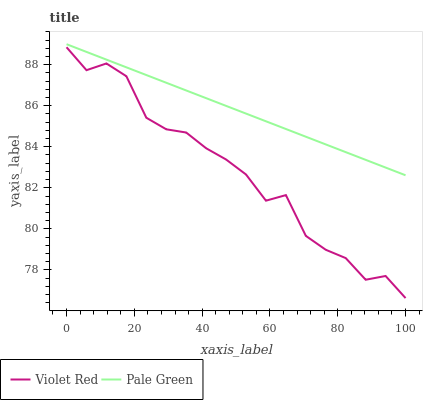Does Violet Red have the minimum area under the curve?
Answer yes or no. Yes. Does Pale Green have the maximum area under the curve?
Answer yes or no. Yes. Does Pale Green have the minimum area under the curve?
Answer yes or no. No. Is Pale Green the smoothest?
Answer yes or no. Yes. Is Violet Red the roughest?
Answer yes or no. Yes. Is Pale Green the roughest?
Answer yes or no. No. Does Violet Red have the lowest value?
Answer yes or no. Yes. Does Pale Green have the lowest value?
Answer yes or no. No. Does Pale Green have the highest value?
Answer yes or no. Yes. Is Violet Red less than Pale Green?
Answer yes or no. Yes. Is Pale Green greater than Violet Red?
Answer yes or no. Yes. Does Violet Red intersect Pale Green?
Answer yes or no. No. 